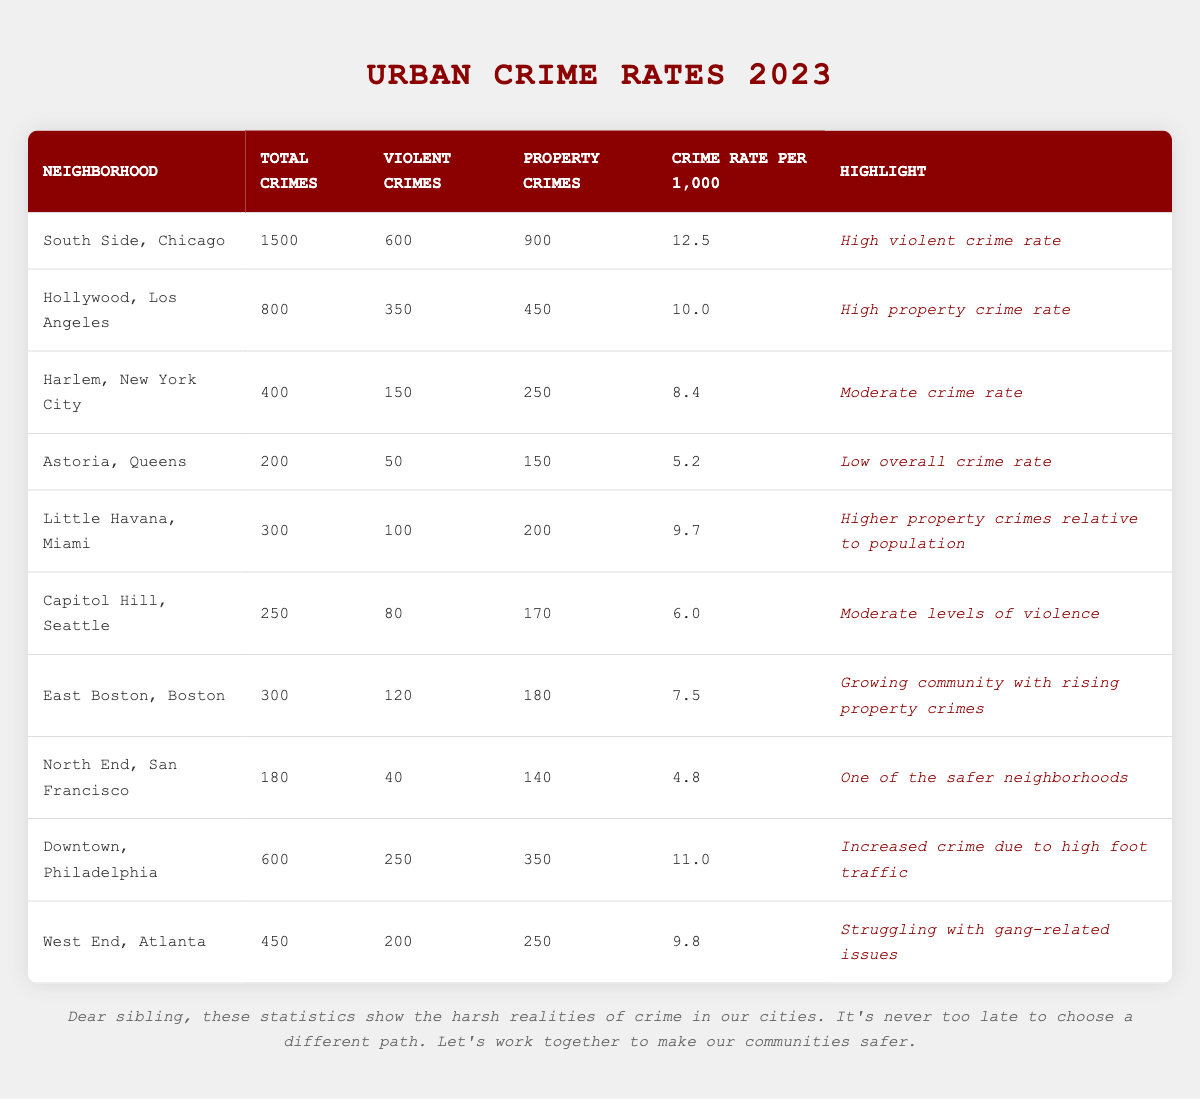What neighborhood has the highest total number of crimes? By examining the total crimes column, South Side, Chicago has the highest total number of crimes at 1500.
Answer: South Side, Chicago Which neighborhood has the lowest crime rate per 1,000 residents? Looking at the crime rates per 1,000, North End, San Francisco has the lowest rate at 4.8.
Answer: North End, San Francisco What is the total number of property crimes in Downtown, Philadelphia? In the total crimes breakdown, Downtown, Philadelphia has 350 property crimes listed.
Answer: 350 Is there a neighborhood with both low overall crime rate and low violent crime rate? Yes, Astoria, Queens has a low overall crime rate of 5.2 and a low violent crime count of 50.
Answer: Yes What is the difference in total crimes between Hollywood, Los Angeles and West End, Atlanta? Calculating the difference: Hollywood has 800 total crimes and West End has 450, so 800 - 450 = 350.
Answer: 350 Which neighborhood has a moderate crime rate and what are its statistics? Harlem, New York City has a moderate crime rate of 8.4, with 400 total crimes, 150 violent crimes, and 250 property crimes.
Answer: Harlem, New York City What percentage of total crimes in South Side, Chicago are violent crimes? The formula for percentage is (violence crimes / total crimes) * 100. Here, (600 / 1500) * 100 = 40%.
Answer: 40% How many neighborhoods have a total crime count of over 400? By counting the neighborhoods with total crimes above 400, we find South Side (1500), Hollywood (800), Downtown (600), West End (450), and Harlem (400) which sums up to 5 neighborhoods.
Answer: 5 Which neighborhood shows signs of struggling with gang-related issues? West End, Atlanta has a highlight indicating it is struggling with gang-related issues.
Answer: West End, Atlanta From the data, which two neighborhoods have the highest and lowest violent crime counts? South Side, Chicago has the highest violent crime count of 600, while North End, San Francisco has the lowest with 40.
Answer: South Side, Chicago; North End, San Francisco 